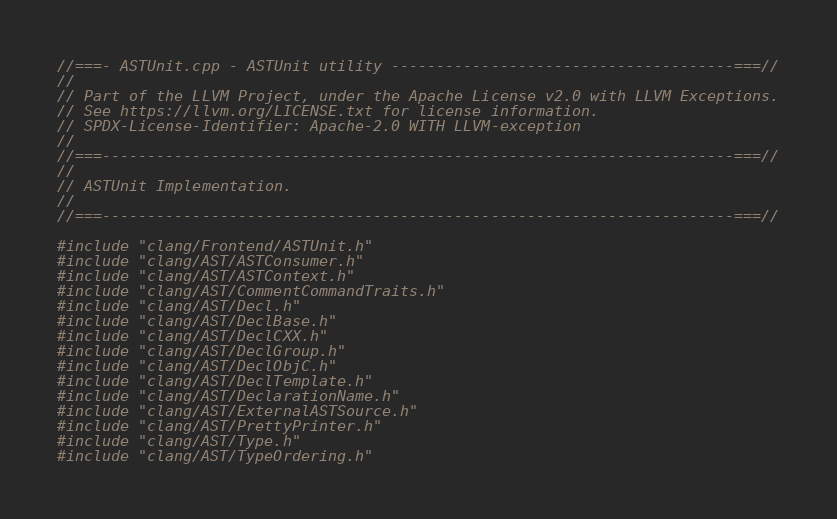<code> <loc_0><loc_0><loc_500><loc_500><_C++_>//===- ASTUnit.cpp - ASTUnit utility --------------------------------------===//
//
// Part of the LLVM Project, under the Apache License v2.0 with LLVM Exceptions.
// See https://llvm.org/LICENSE.txt for license information.
// SPDX-License-Identifier: Apache-2.0 WITH LLVM-exception
//
//===----------------------------------------------------------------------===//
//
// ASTUnit Implementation.
//
//===----------------------------------------------------------------------===//

#include "clang/Frontend/ASTUnit.h"
#include "clang/AST/ASTConsumer.h"
#include "clang/AST/ASTContext.h"
#include "clang/AST/CommentCommandTraits.h"
#include "clang/AST/Decl.h"
#include "clang/AST/DeclBase.h"
#include "clang/AST/DeclCXX.h"
#include "clang/AST/DeclGroup.h"
#include "clang/AST/DeclObjC.h"
#include "clang/AST/DeclTemplate.h"
#include "clang/AST/DeclarationName.h"
#include "clang/AST/ExternalASTSource.h"
#include "clang/AST/PrettyPrinter.h"
#include "clang/AST/Type.h"
#include "clang/AST/TypeOrdering.h"</code> 